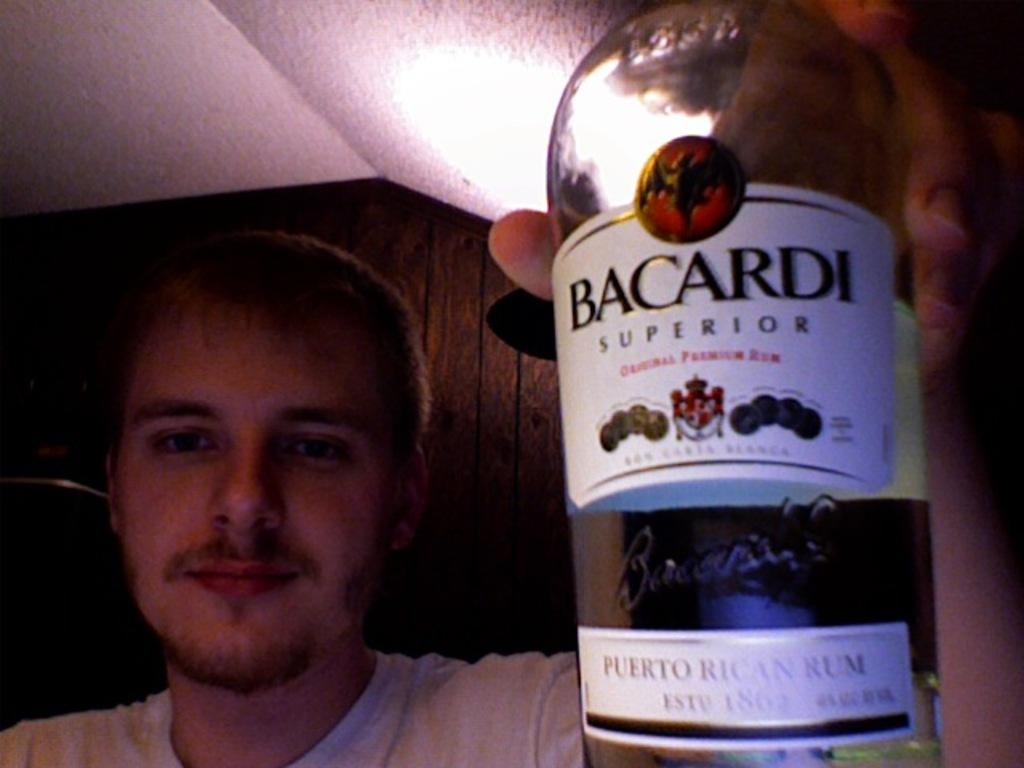Who or what is present in the image? There is a person in the image. What is the person wearing? The person is wearing a white shirt. What is the person holding in the image? The person is holding a bottle. What is written on the bottle? The bottle is labelled as "Bacardi Superior." Where is the donkey in the image? There is no donkey present in the image. What type of cactus can be seen in the background of the image? There is no cactus visible in the image. 